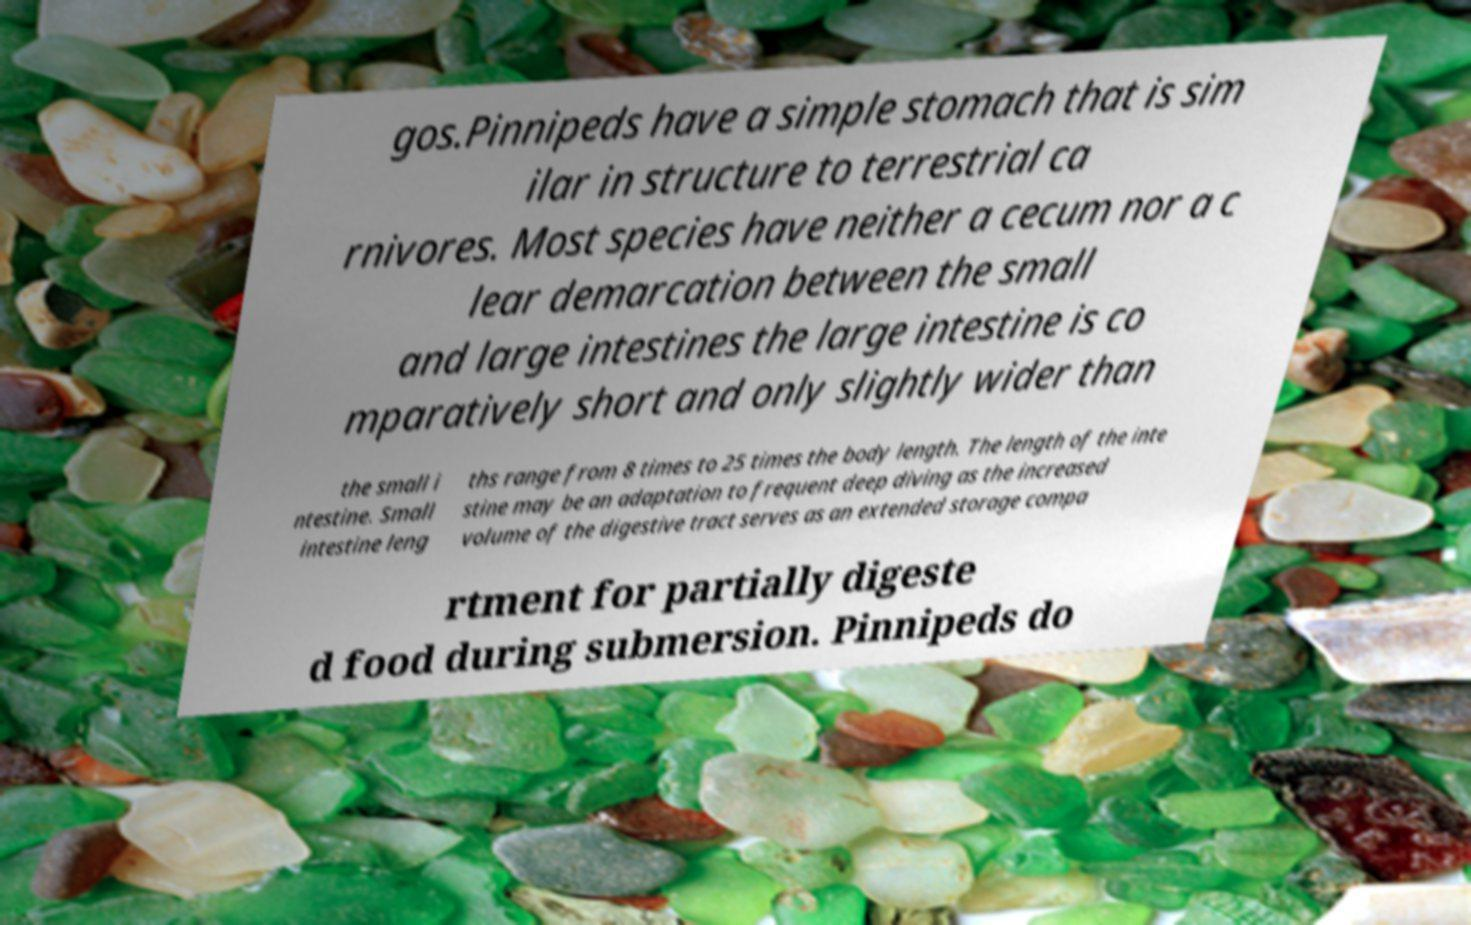For documentation purposes, I need the text within this image transcribed. Could you provide that? gos.Pinnipeds have a simple stomach that is sim ilar in structure to terrestrial ca rnivores. Most species have neither a cecum nor a c lear demarcation between the small and large intestines the large intestine is co mparatively short and only slightly wider than the small i ntestine. Small intestine leng ths range from 8 times to 25 times the body length. The length of the inte stine may be an adaptation to frequent deep diving as the increased volume of the digestive tract serves as an extended storage compa rtment for partially digeste d food during submersion. Pinnipeds do 